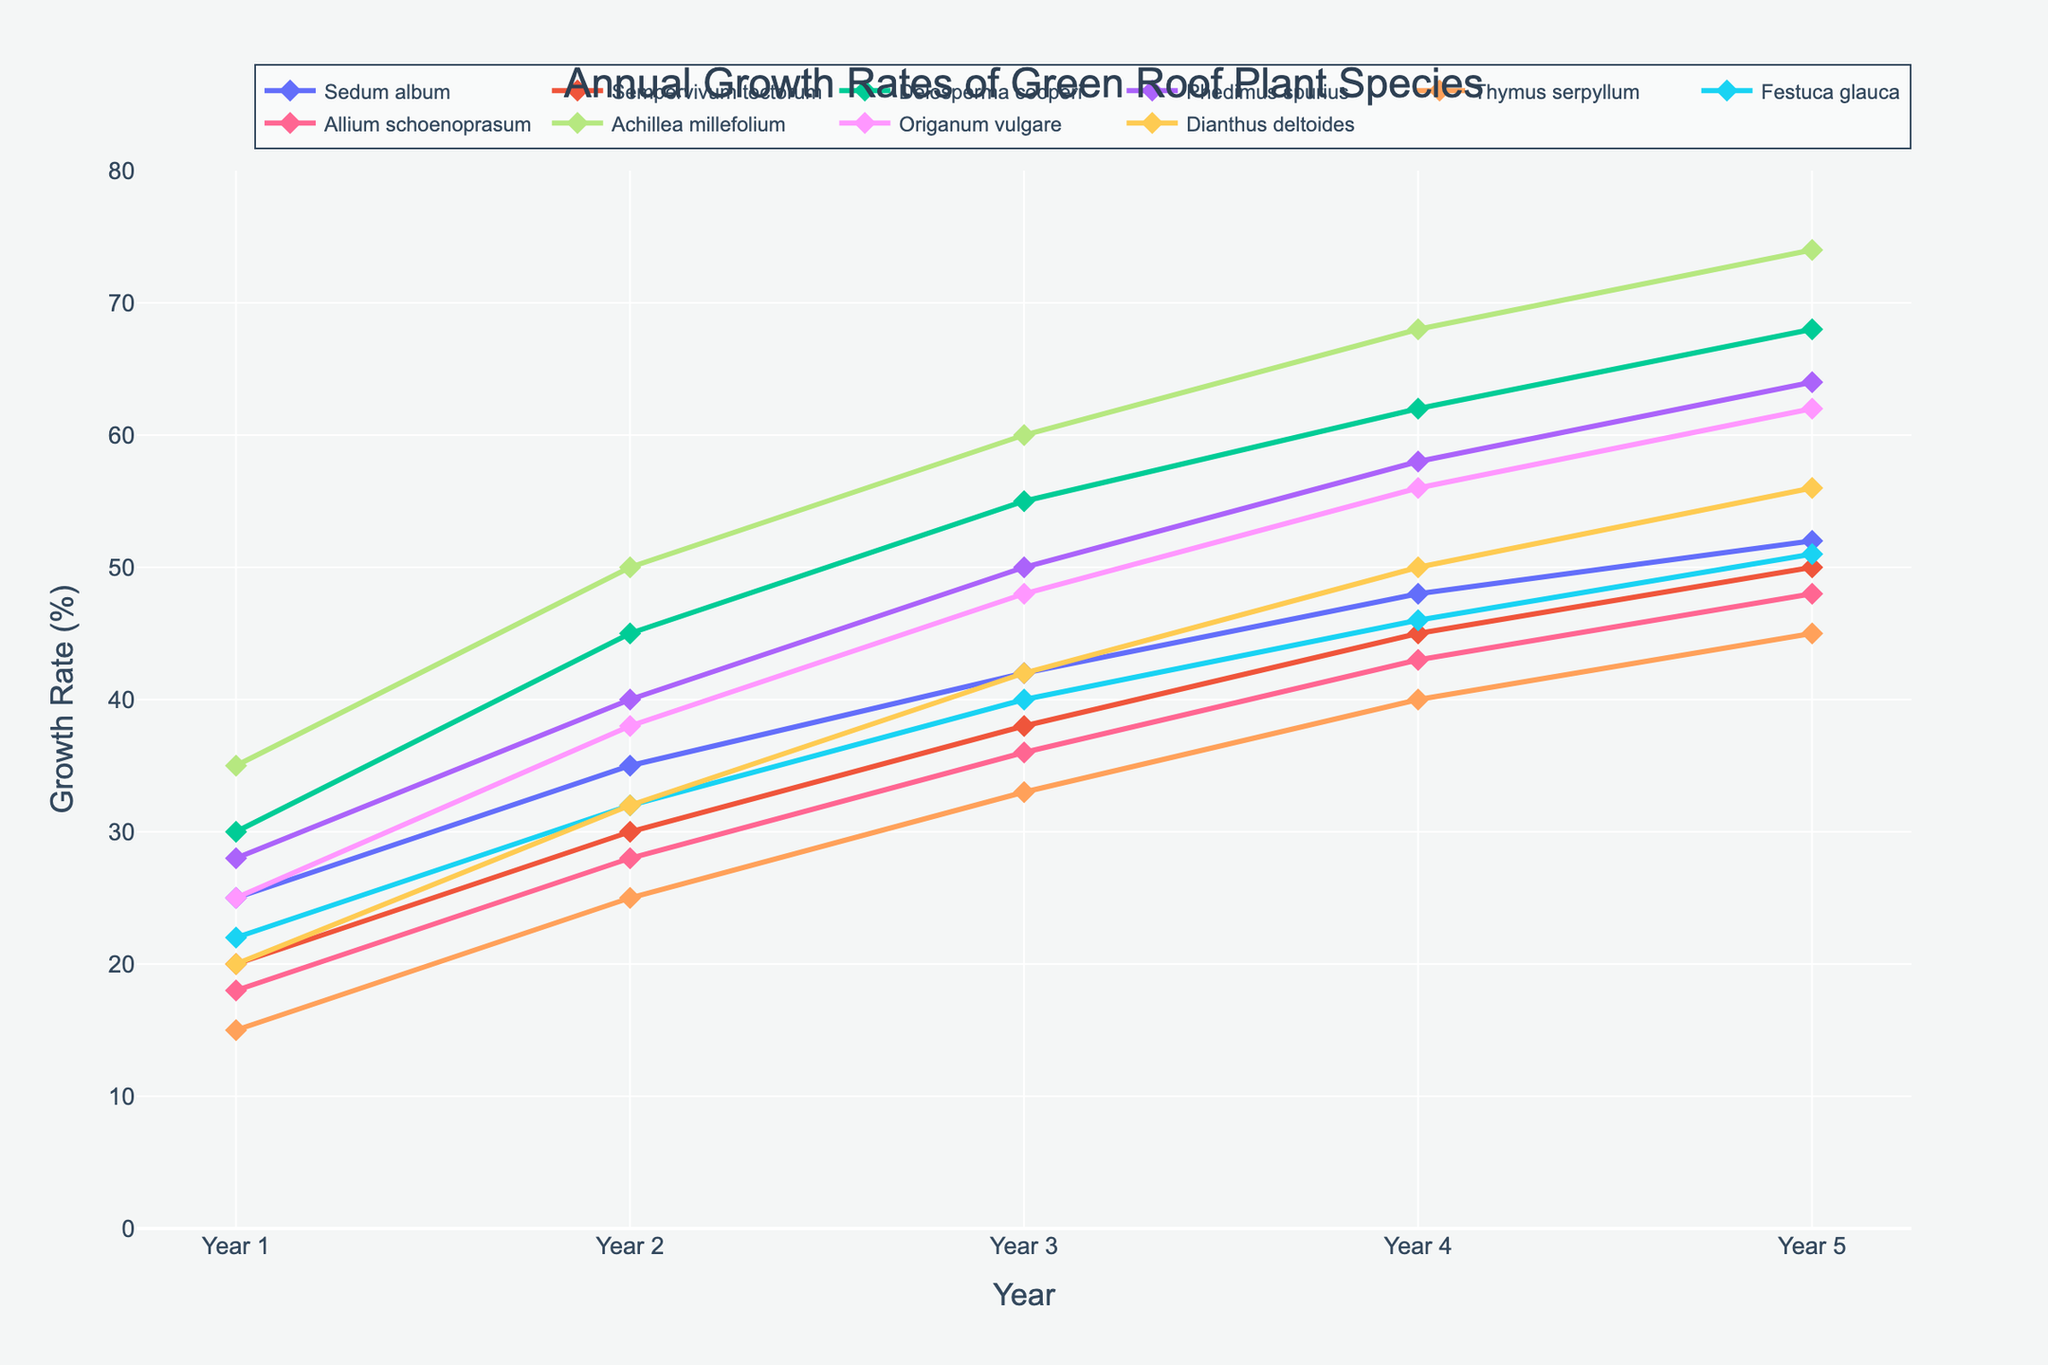Which plant species showed the highest growth rate increase from Year 1 to Year 5? Look at the starting and ending points of each line for the species. Achillea millefolium starts at 35 and ends at 74, which is the highest increase.
Answer: Achillea millefolium What is the average growth rate of Sedum album over the 5 years? Add the growth rates for Sedum album: 25 + 35 + 42 + 48 + 52 = 202. Then divide by 5: 202/5 = 40.4.
Answer: 40.4 Which two species have the closest growth rates in Year 4? In Year 4, Sempervivum tectorum has 45 and Allium schoenoprasum has 43. The difference is 2, which is the smallest difference compared to other species pairs.
Answer: Sempervivum tectorum and Allium schoenoprasum By how much did the growth rate of Thymus serpyllum increase between Year 2 and Year 5? Thymus serpyllum grew from 25 to 45 between Year 2 and Year 5. The increase is 45 - 25 = 20.
Answer: 20 Which species had a higher growth rate in Year 3, Delosperma cooperi or Festuca glauca? Delosperma cooperi had a growth rate of 55 in Year 3, while Festuca glauca had a growth rate of 40. 55 is higher than 40.
Answer: Delosperma cooperi How does the growth rate trend of Sedum album compare to Thymus serpyllum? Sedum album increases steadily each year from 25 to 52. Thymus serpyllum also increases each year but starts lower at 15 and increases to 45. Both show steady increases, but Sedum album ends with a higher rate.
Answer: Both have steady increases, Sedum album ends higher What is the sum of the growth rates for Phedimus spurius and Origanum vulgare in Year 5? In Year 5, Phedimus spurius has a growth rate of 64 and Origanum vulgare has 62. The sum is 64 + 62 = 126.
Answer: 126 Which species showed the smallest growth rate in Year 1? Visually inspect the starting points of each species' line. Thymus serpyllum starts at 15, which is the smallest.
Answer: Thymus serpyllum 